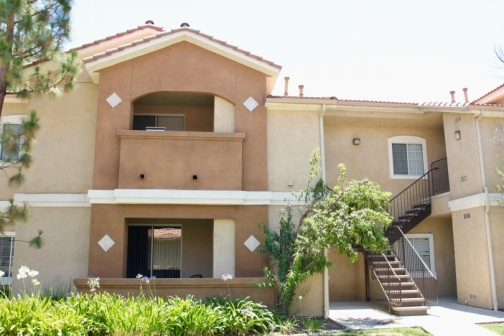Can you describe the weather conditions in the image? The weather in the image appears to be clear and sunny. The lighting suggests midday sunlight, casting minimal shadows which indicates bright and favorable weather conditions. The sky likely has few, if any, clouds, contributing to the bright and inviting atmosphere of the residential area. 